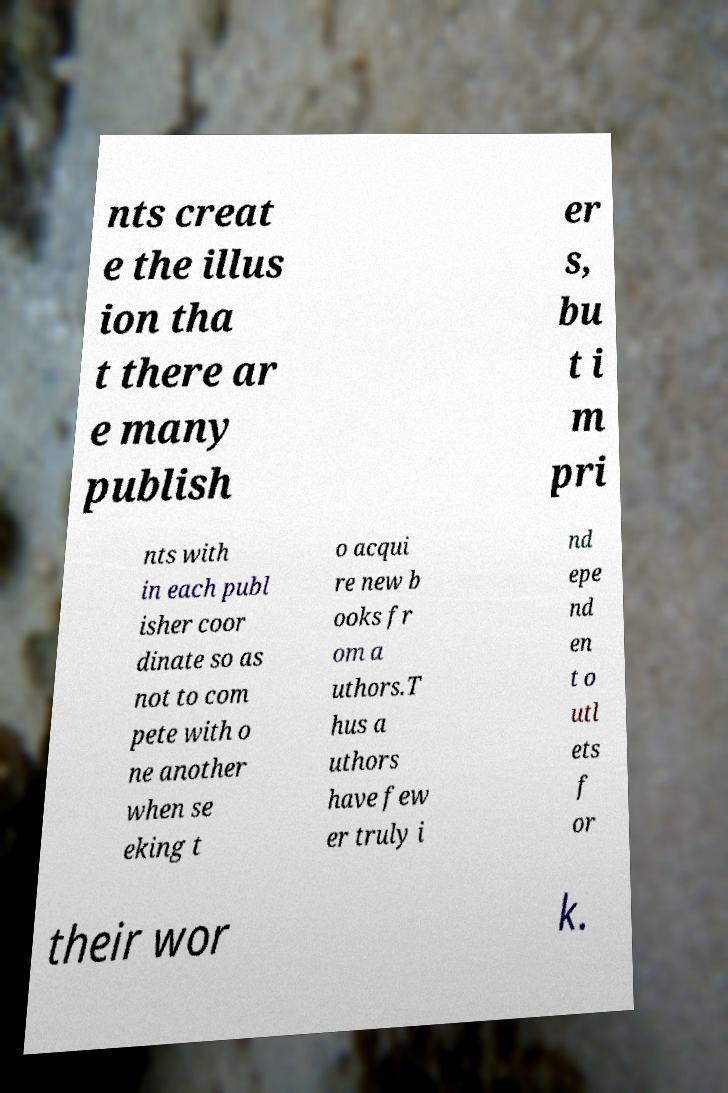For documentation purposes, I need the text within this image transcribed. Could you provide that? nts creat e the illus ion tha t there ar e many publish er s, bu t i m pri nts with in each publ isher coor dinate so as not to com pete with o ne another when se eking t o acqui re new b ooks fr om a uthors.T hus a uthors have few er truly i nd epe nd en t o utl ets f or their wor k. 